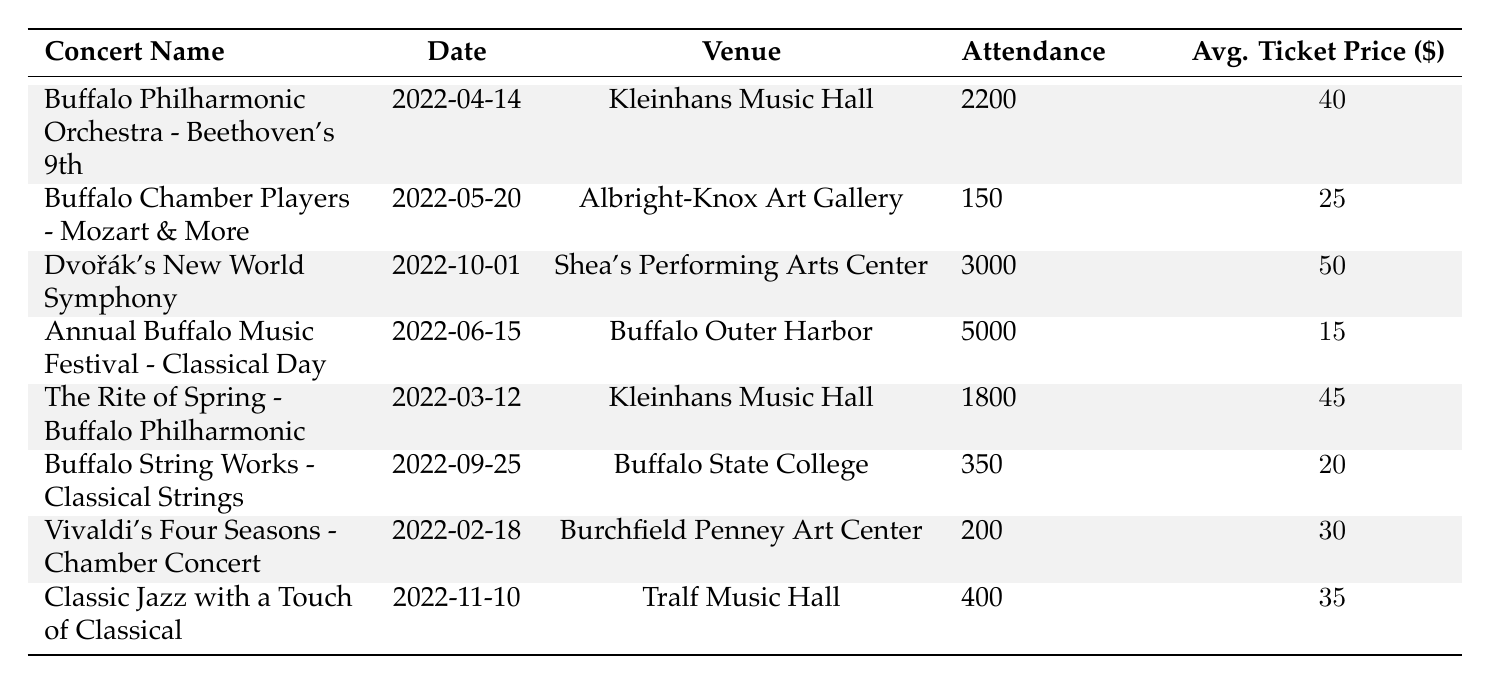What concert had the highest attendance in 2022? By examining the Attendance column in the table, we can see that the concert "Annual Buffalo Music Festival - Classical Day" had the highest attendance with 5000 attendees.
Answer: 5000 How many concerts were held at Kleinhans Music Hall? Looking through the Venue column, the concerts held at Kleinhans Music Hall are: "Buffalo Philharmonic Orchestra - Beethoven's 9th" and "The Rite of Spring - Buffalo Philharmonic". This gives us a total of 2 concerts.
Answer: 2 What was the average ticket price for the concerts in Buffalo in 2022? To calculate the average ticket price, we sum the Average Ticket Price values: (40 + 25 + 50 + 15 + 45 + 20 + 30 + 35) = 315. There are 8 concerts, so the average is 315 / 8 = 39.375.
Answer: 39.375 Did any concert have an attendance of less than 200? By checking the Attendance column, the concerts with attendance figures are: 2200, 150, 3000, 5000, 1800, 350, 200, and 400. The lowest figure is 150. Thus, there was a concert with attendance of less than 200.
Answer: Yes What is the total attendance for concerts held in June 2022? In June 2022, only one concert took place: "Annual Buffalo Music Festival - Classical Day," which had an attendance of 5000. Therefore, the total attendance for that month is 5000.
Answer: 5000 Which concert had the highest average ticket price, and what was it? Reviewing the Average Ticket Price column, "Dvořák's New World Symphony" had the highest average ticket price of 50.
Answer: 50 What was the total attendance for concerts held in the last quarter of 2022 (October and November)? In this period, there were two concerts: "Dvořák's New World Symphony" with 3000 attendees and "Classic Jazz with a Touch of Classical" with 400 attendees. Adding these gives 3000 + 400 = 3400 for total attendance.
Answer: 3400 Was the average ticket price lower for concerts with over 2000 attendees compared to those with 2000 or fewer? The concerts with over 2000 attendees are: "Buffalo Philharmonic Orchestra - Beethoven's 9th" (40) and "Dvořák's New World Symphony" (50), averaging (40 + 50) / 2 = 45. The concerts with 2000 or fewer attendees are: "Buffalo Chamber Players - Mozart & More" (25), "The Rite of Spring - Buffalo Philharmonic" (45), "Buffalo String Works - Classical Strings" (20), "Vivaldi's Four Seasons" (30), and "Classic Jazz with a Touch of Classical" (35), averaging (25 + 45 + 20 + 30 + 35) / 5 = 31.
Answer: No What is the difference in attendance between the concert with the highest and the lowest attendance? The highest attendance is 5000 ("Annual Buffalo Music Festival - Classical Day") and the lowest attendance is 150 ("Buffalo Chamber Players - Mozart & More"). The difference is 5000 - 150 = 4850.
Answer: 4850 